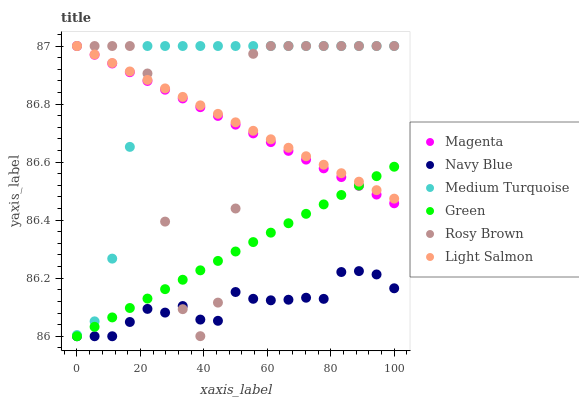Does Navy Blue have the minimum area under the curve?
Answer yes or no. Yes. Does Medium Turquoise have the maximum area under the curve?
Answer yes or no. Yes. Does Rosy Brown have the minimum area under the curve?
Answer yes or no. No. Does Rosy Brown have the maximum area under the curve?
Answer yes or no. No. Is Green the smoothest?
Answer yes or no. Yes. Is Rosy Brown the roughest?
Answer yes or no. Yes. Is Navy Blue the smoothest?
Answer yes or no. No. Is Navy Blue the roughest?
Answer yes or no. No. Does Navy Blue have the lowest value?
Answer yes or no. Yes. Does Rosy Brown have the lowest value?
Answer yes or no. No. Does Magenta have the highest value?
Answer yes or no. Yes. Does Navy Blue have the highest value?
Answer yes or no. No. Is Navy Blue less than Light Salmon?
Answer yes or no. Yes. Is Medium Turquoise greater than Green?
Answer yes or no. Yes. Does Medium Turquoise intersect Magenta?
Answer yes or no. Yes. Is Medium Turquoise less than Magenta?
Answer yes or no. No. Is Medium Turquoise greater than Magenta?
Answer yes or no. No. Does Navy Blue intersect Light Salmon?
Answer yes or no. No. 